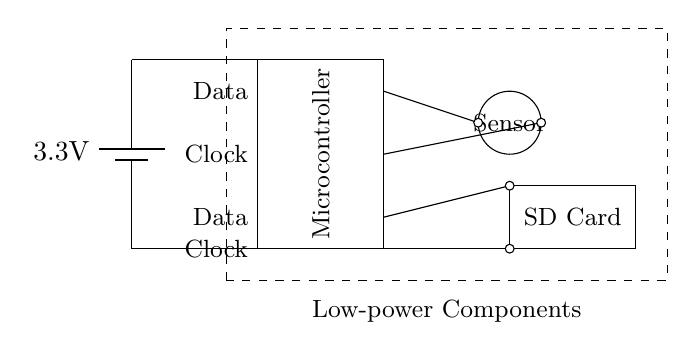What is the voltage of this circuit? The voltage is 3.3 volts, indicated by the battery symbol at the top of the circuit diagram. The voltage value marked beside the battery is the supply voltage for the circuit.
Answer: 3.3 volts What components are included in this circuit? The circuit includes three main components: a microcontroller, a sensor, and an SD card. Each component is represented in the diagram, with labels clarifying their identities.
Answer: Microcontroller, Sensor, SD Card How many connections are made to the microcontroller? The microcontroller has four connections made to it: two for data and two for clock signals, as shown by the short lines connecting it to other components.
Answer: Four What purpose does the SD card serve in this circuit? The SD card is used for data storage. It is positioned in the circuit for data output from the microcontroller, allowing recorded data from the sensor to be saved.
Answer: Data storage What type of circuit is illustrated in this diagram? The circuit can be classified as a low-power circuit, specifically designed for data logging devices in sociological research, as indicated by the dashed box labeling the low-power components in the diagram.
Answer: Low-power circuit How does the sensor connect to the microcontroller? The sensor connects to the microcontroller through a direct line, enabling the flow of data from the sensor to the microcontroller for processing. The connection is clearly depicted with a short line leading from the sensor to the microcontroller.
Answer: Direct connection 